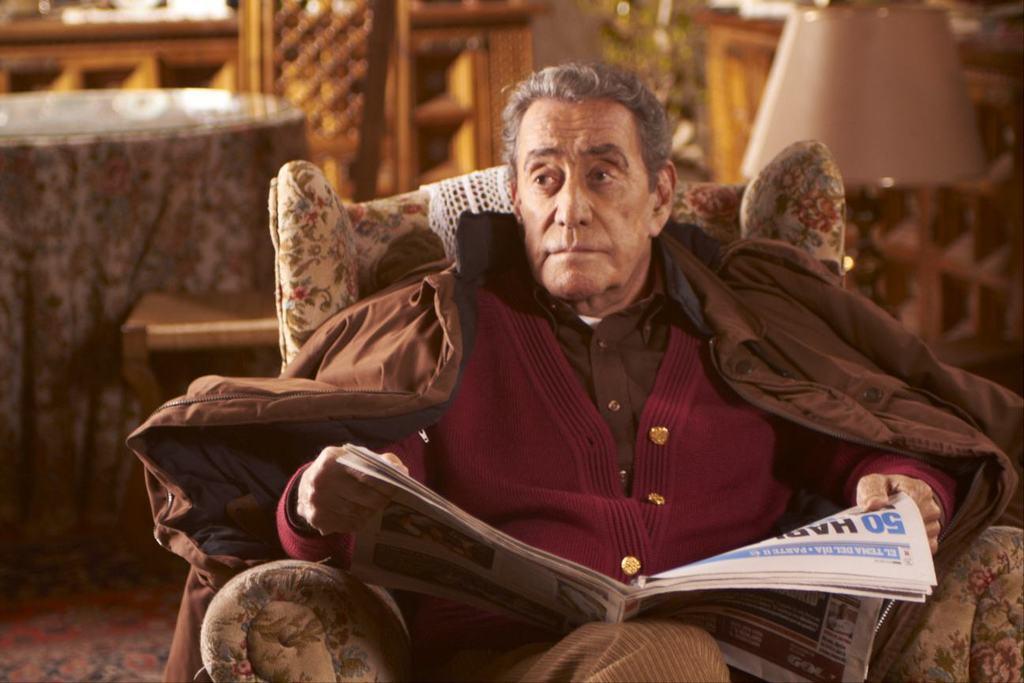Describe this image in one or two sentences. In this image we can see a man sitting on the couch and holding newspaper in his hands. In the background we can see side table, cupboard and a plant. 